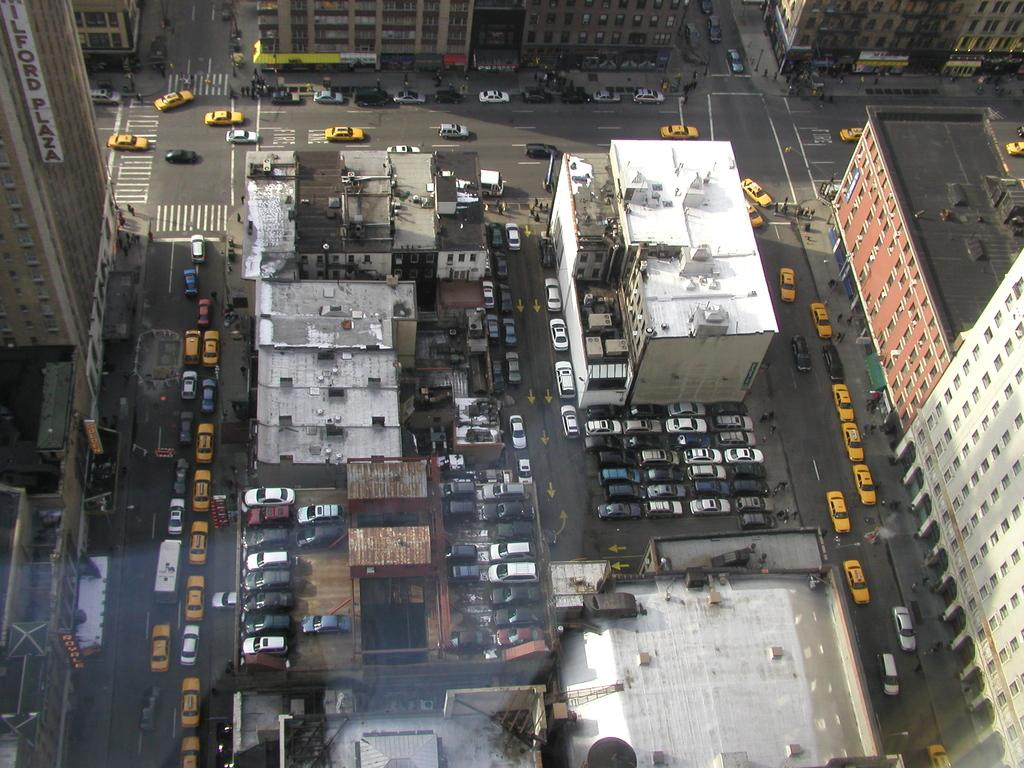What is happening on the roads in the image? There are vehicles on the roads in the image. What are the people doing in front of the buildings? There are people walking in front of the buildings in the image. What type of structures can be seen in the image? There are buildings visible in the image. Is there snow covering the buildings in the image? There is no mention of snow in the provided facts, and therefore it cannot be determined if snow is present in the image. How does the person in the image provide support to the buildings? There is no person mentioned in the provided facts, and therefore it cannot be determined if someone is providing support to the buildings. 